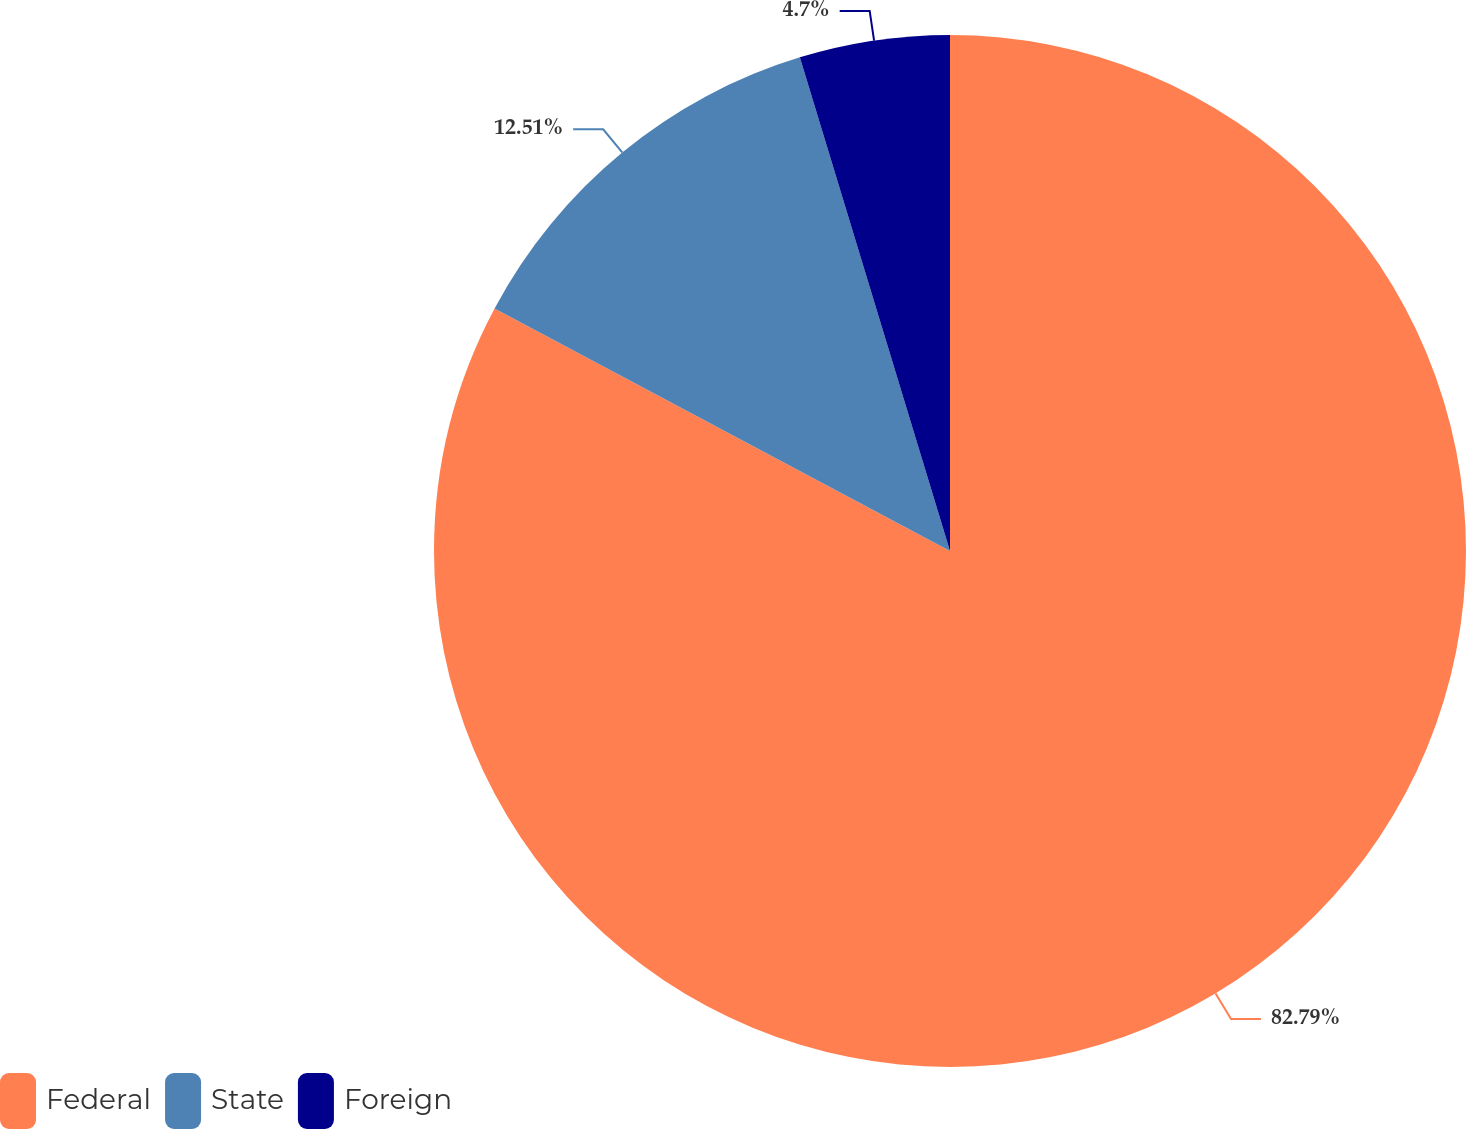Convert chart. <chart><loc_0><loc_0><loc_500><loc_500><pie_chart><fcel>Federal<fcel>State<fcel>Foreign<nl><fcel>82.79%<fcel>12.51%<fcel>4.7%<nl></chart> 